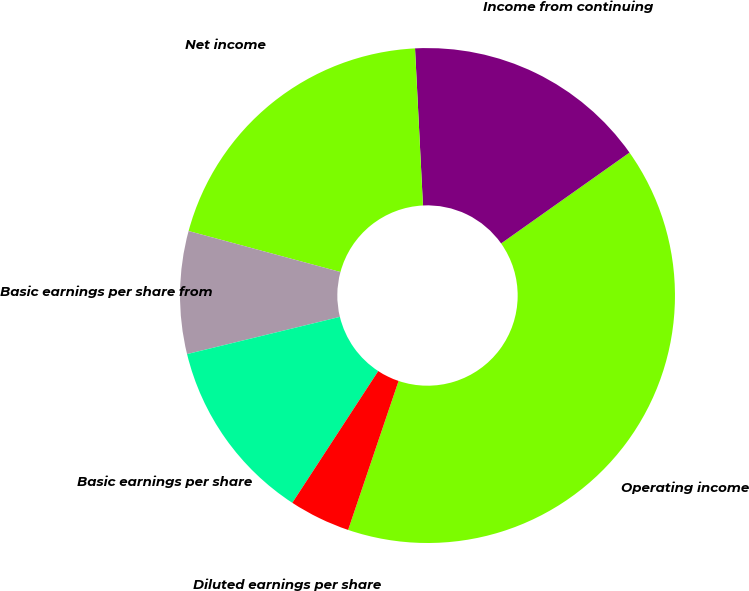Convert chart to OTSL. <chart><loc_0><loc_0><loc_500><loc_500><pie_chart><fcel>Operating income<fcel>Income from continuing<fcel>Net income<fcel>Basic earnings per share from<fcel>Basic earnings per share<fcel>Diluted earnings per share<nl><fcel>40.0%<fcel>16.0%<fcel>20.0%<fcel>8.0%<fcel>12.0%<fcel>4.0%<nl></chart> 